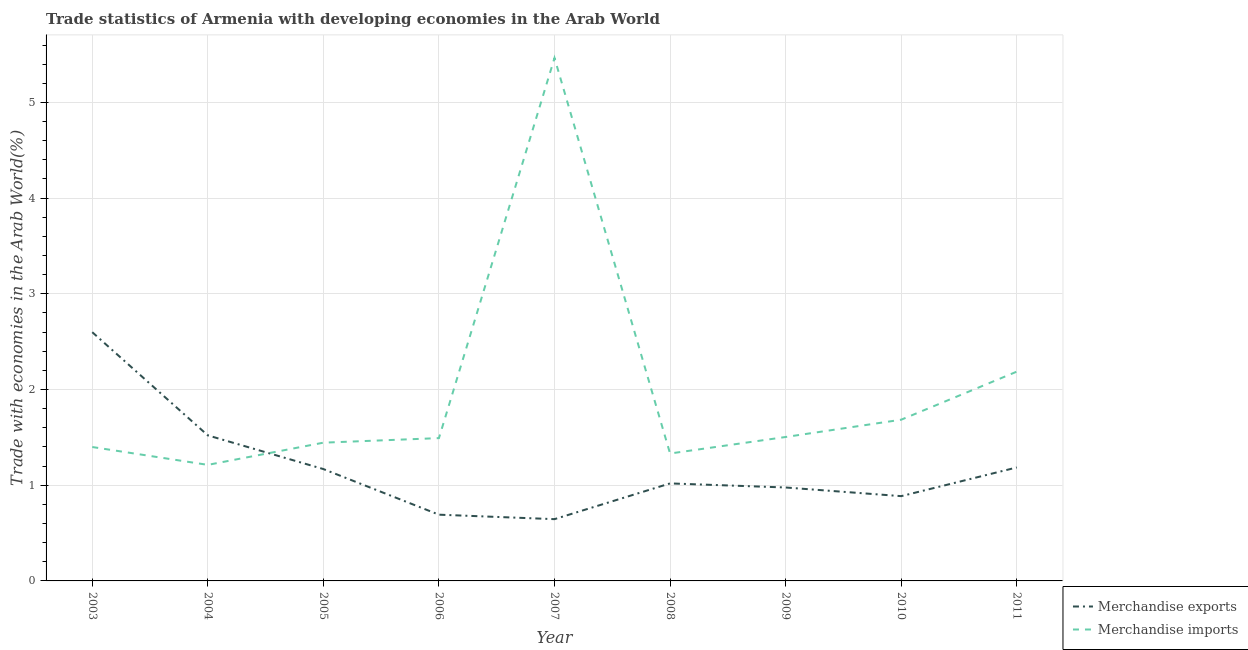How many different coloured lines are there?
Give a very brief answer. 2. What is the merchandise exports in 2011?
Offer a terse response. 1.19. Across all years, what is the maximum merchandise imports?
Offer a terse response. 5.47. Across all years, what is the minimum merchandise imports?
Your answer should be compact. 1.21. In which year was the merchandise imports maximum?
Keep it short and to the point. 2007. In which year was the merchandise exports minimum?
Your response must be concise. 2007. What is the total merchandise exports in the graph?
Keep it short and to the point. 10.69. What is the difference between the merchandise imports in 2007 and that in 2008?
Your answer should be very brief. 4.13. What is the difference between the merchandise imports in 2007 and the merchandise exports in 2005?
Provide a short and direct response. 4.3. What is the average merchandise imports per year?
Give a very brief answer. 1.97. In the year 2010, what is the difference between the merchandise exports and merchandise imports?
Offer a terse response. -0.8. What is the ratio of the merchandise exports in 2003 to that in 2006?
Offer a terse response. 3.76. What is the difference between the highest and the second highest merchandise imports?
Make the answer very short. 3.28. What is the difference between the highest and the lowest merchandise exports?
Your answer should be compact. 1.95. In how many years, is the merchandise exports greater than the average merchandise exports taken over all years?
Your answer should be very brief. 2. Is the merchandise imports strictly less than the merchandise exports over the years?
Offer a very short reply. No. How many lines are there?
Your response must be concise. 2. How many years are there in the graph?
Provide a short and direct response. 9. Does the graph contain any zero values?
Make the answer very short. No. Does the graph contain grids?
Offer a terse response. Yes. How are the legend labels stacked?
Offer a very short reply. Vertical. What is the title of the graph?
Your answer should be very brief. Trade statistics of Armenia with developing economies in the Arab World. What is the label or title of the X-axis?
Provide a succinct answer. Year. What is the label or title of the Y-axis?
Ensure brevity in your answer.  Trade with economies in the Arab World(%). What is the Trade with economies in the Arab World(%) in Merchandise exports in 2003?
Keep it short and to the point. 2.6. What is the Trade with economies in the Arab World(%) in Merchandise imports in 2003?
Offer a very short reply. 1.4. What is the Trade with economies in the Arab World(%) of Merchandise exports in 2004?
Your answer should be compact. 1.52. What is the Trade with economies in the Arab World(%) of Merchandise imports in 2004?
Make the answer very short. 1.21. What is the Trade with economies in the Arab World(%) in Merchandise exports in 2005?
Give a very brief answer. 1.17. What is the Trade with economies in the Arab World(%) of Merchandise imports in 2005?
Offer a very short reply. 1.44. What is the Trade with economies in the Arab World(%) of Merchandise exports in 2006?
Provide a short and direct response. 0.69. What is the Trade with economies in the Arab World(%) in Merchandise imports in 2006?
Make the answer very short. 1.49. What is the Trade with economies in the Arab World(%) of Merchandise exports in 2007?
Keep it short and to the point. 0.65. What is the Trade with economies in the Arab World(%) in Merchandise imports in 2007?
Keep it short and to the point. 5.47. What is the Trade with economies in the Arab World(%) of Merchandise exports in 2008?
Keep it short and to the point. 1.02. What is the Trade with economies in the Arab World(%) of Merchandise imports in 2008?
Provide a succinct answer. 1.33. What is the Trade with economies in the Arab World(%) of Merchandise exports in 2009?
Your answer should be compact. 0.98. What is the Trade with economies in the Arab World(%) of Merchandise imports in 2009?
Your response must be concise. 1.5. What is the Trade with economies in the Arab World(%) of Merchandise exports in 2010?
Your response must be concise. 0.89. What is the Trade with economies in the Arab World(%) in Merchandise imports in 2010?
Your response must be concise. 1.68. What is the Trade with economies in the Arab World(%) of Merchandise exports in 2011?
Provide a succinct answer. 1.19. What is the Trade with economies in the Arab World(%) of Merchandise imports in 2011?
Make the answer very short. 2.19. Across all years, what is the maximum Trade with economies in the Arab World(%) of Merchandise exports?
Ensure brevity in your answer.  2.6. Across all years, what is the maximum Trade with economies in the Arab World(%) of Merchandise imports?
Your response must be concise. 5.47. Across all years, what is the minimum Trade with economies in the Arab World(%) of Merchandise exports?
Make the answer very short. 0.65. Across all years, what is the minimum Trade with economies in the Arab World(%) of Merchandise imports?
Your answer should be compact. 1.21. What is the total Trade with economies in the Arab World(%) of Merchandise exports in the graph?
Your answer should be compact. 10.69. What is the total Trade with economies in the Arab World(%) of Merchandise imports in the graph?
Offer a very short reply. 17.72. What is the difference between the Trade with economies in the Arab World(%) in Merchandise exports in 2003 and that in 2004?
Ensure brevity in your answer.  1.08. What is the difference between the Trade with economies in the Arab World(%) in Merchandise imports in 2003 and that in 2004?
Offer a terse response. 0.19. What is the difference between the Trade with economies in the Arab World(%) of Merchandise exports in 2003 and that in 2005?
Keep it short and to the point. 1.43. What is the difference between the Trade with economies in the Arab World(%) of Merchandise imports in 2003 and that in 2005?
Give a very brief answer. -0.05. What is the difference between the Trade with economies in the Arab World(%) in Merchandise exports in 2003 and that in 2006?
Keep it short and to the point. 1.91. What is the difference between the Trade with economies in the Arab World(%) of Merchandise imports in 2003 and that in 2006?
Give a very brief answer. -0.09. What is the difference between the Trade with economies in the Arab World(%) in Merchandise exports in 2003 and that in 2007?
Your answer should be compact. 1.95. What is the difference between the Trade with economies in the Arab World(%) in Merchandise imports in 2003 and that in 2007?
Provide a succinct answer. -4.07. What is the difference between the Trade with economies in the Arab World(%) of Merchandise exports in 2003 and that in 2008?
Make the answer very short. 1.58. What is the difference between the Trade with economies in the Arab World(%) in Merchandise imports in 2003 and that in 2008?
Your response must be concise. 0.07. What is the difference between the Trade with economies in the Arab World(%) in Merchandise exports in 2003 and that in 2009?
Offer a very short reply. 1.62. What is the difference between the Trade with economies in the Arab World(%) in Merchandise imports in 2003 and that in 2009?
Provide a succinct answer. -0.1. What is the difference between the Trade with economies in the Arab World(%) of Merchandise exports in 2003 and that in 2010?
Your response must be concise. 1.71. What is the difference between the Trade with economies in the Arab World(%) of Merchandise imports in 2003 and that in 2010?
Provide a short and direct response. -0.29. What is the difference between the Trade with economies in the Arab World(%) of Merchandise exports in 2003 and that in 2011?
Provide a short and direct response. 1.41. What is the difference between the Trade with economies in the Arab World(%) of Merchandise imports in 2003 and that in 2011?
Provide a short and direct response. -0.79. What is the difference between the Trade with economies in the Arab World(%) in Merchandise exports in 2004 and that in 2005?
Your response must be concise. 0.35. What is the difference between the Trade with economies in the Arab World(%) of Merchandise imports in 2004 and that in 2005?
Your answer should be compact. -0.23. What is the difference between the Trade with economies in the Arab World(%) in Merchandise exports in 2004 and that in 2006?
Your response must be concise. 0.83. What is the difference between the Trade with economies in the Arab World(%) of Merchandise imports in 2004 and that in 2006?
Your answer should be very brief. -0.28. What is the difference between the Trade with economies in the Arab World(%) of Merchandise exports in 2004 and that in 2007?
Offer a terse response. 0.88. What is the difference between the Trade with economies in the Arab World(%) in Merchandise imports in 2004 and that in 2007?
Ensure brevity in your answer.  -4.25. What is the difference between the Trade with economies in the Arab World(%) in Merchandise exports in 2004 and that in 2008?
Ensure brevity in your answer.  0.5. What is the difference between the Trade with economies in the Arab World(%) in Merchandise imports in 2004 and that in 2008?
Keep it short and to the point. -0.12. What is the difference between the Trade with economies in the Arab World(%) of Merchandise exports in 2004 and that in 2009?
Your answer should be compact. 0.54. What is the difference between the Trade with economies in the Arab World(%) in Merchandise imports in 2004 and that in 2009?
Make the answer very short. -0.29. What is the difference between the Trade with economies in the Arab World(%) in Merchandise exports in 2004 and that in 2010?
Make the answer very short. 0.63. What is the difference between the Trade with economies in the Arab World(%) of Merchandise imports in 2004 and that in 2010?
Your response must be concise. -0.47. What is the difference between the Trade with economies in the Arab World(%) in Merchandise exports in 2004 and that in 2011?
Your response must be concise. 0.34. What is the difference between the Trade with economies in the Arab World(%) of Merchandise imports in 2004 and that in 2011?
Offer a very short reply. -0.97. What is the difference between the Trade with economies in the Arab World(%) of Merchandise exports in 2005 and that in 2006?
Your answer should be compact. 0.48. What is the difference between the Trade with economies in the Arab World(%) of Merchandise imports in 2005 and that in 2006?
Ensure brevity in your answer.  -0.05. What is the difference between the Trade with economies in the Arab World(%) of Merchandise exports in 2005 and that in 2007?
Provide a short and direct response. 0.52. What is the difference between the Trade with economies in the Arab World(%) in Merchandise imports in 2005 and that in 2007?
Your answer should be compact. -4.02. What is the difference between the Trade with economies in the Arab World(%) in Merchandise exports in 2005 and that in 2008?
Offer a terse response. 0.15. What is the difference between the Trade with economies in the Arab World(%) of Merchandise imports in 2005 and that in 2008?
Give a very brief answer. 0.11. What is the difference between the Trade with economies in the Arab World(%) in Merchandise exports in 2005 and that in 2009?
Your response must be concise. 0.19. What is the difference between the Trade with economies in the Arab World(%) in Merchandise imports in 2005 and that in 2009?
Ensure brevity in your answer.  -0.06. What is the difference between the Trade with economies in the Arab World(%) of Merchandise exports in 2005 and that in 2010?
Make the answer very short. 0.28. What is the difference between the Trade with economies in the Arab World(%) of Merchandise imports in 2005 and that in 2010?
Your response must be concise. -0.24. What is the difference between the Trade with economies in the Arab World(%) of Merchandise exports in 2005 and that in 2011?
Offer a terse response. -0.02. What is the difference between the Trade with economies in the Arab World(%) in Merchandise imports in 2005 and that in 2011?
Offer a terse response. -0.74. What is the difference between the Trade with economies in the Arab World(%) in Merchandise exports in 2006 and that in 2007?
Make the answer very short. 0.05. What is the difference between the Trade with economies in the Arab World(%) in Merchandise imports in 2006 and that in 2007?
Provide a succinct answer. -3.97. What is the difference between the Trade with economies in the Arab World(%) in Merchandise exports in 2006 and that in 2008?
Offer a very short reply. -0.33. What is the difference between the Trade with economies in the Arab World(%) in Merchandise imports in 2006 and that in 2008?
Your answer should be compact. 0.16. What is the difference between the Trade with economies in the Arab World(%) in Merchandise exports in 2006 and that in 2009?
Give a very brief answer. -0.28. What is the difference between the Trade with economies in the Arab World(%) in Merchandise imports in 2006 and that in 2009?
Provide a succinct answer. -0.01. What is the difference between the Trade with economies in the Arab World(%) of Merchandise exports in 2006 and that in 2010?
Your answer should be very brief. -0.19. What is the difference between the Trade with economies in the Arab World(%) of Merchandise imports in 2006 and that in 2010?
Offer a terse response. -0.19. What is the difference between the Trade with economies in the Arab World(%) of Merchandise exports in 2006 and that in 2011?
Your response must be concise. -0.49. What is the difference between the Trade with economies in the Arab World(%) in Merchandise imports in 2006 and that in 2011?
Provide a short and direct response. -0.69. What is the difference between the Trade with economies in the Arab World(%) of Merchandise exports in 2007 and that in 2008?
Your answer should be very brief. -0.37. What is the difference between the Trade with economies in the Arab World(%) of Merchandise imports in 2007 and that in 2008?
Offer a terse response. 4.13. What is the difference between the Trade with economies in the Arab World(%) of Merchandise exports in 2007 and that in 2009?
Your response must be concise. -0.33. What is the difference between the Trade with economies in the Arab World(%) of Merchandise imports in 2007 and that in 2009?
Offer a terse response. 3.96. What is the difference between the Trade with economies in the Arab World(%) in Merchandise exports in 2007 and that in 2010?
Offer a terse response. -0.24. What is the difference between the Trade with economies in the Arab World(%) in Merchandise imports in 2007 and that in 2010?
Provide a short and direct response. 3.78. What is the difference between the Trade with economies in the Arab World(%) in Merchandise exports in 2007 and that in 2011?
Your answer should be very brief. -0.54. What is the difference between the Trade with economies in the Arab World(%) in Merchandise imports in 2007 and that in 2011?
Offer a terse response. 3.28. What is the difference between the Trade with economies in the Arab World(%) in Merchandise exports in 2008 and that in 2009?
Give a very brief answer. 0.04. What is the difference between the Trade with economies in the Arab World(%) of Merchandise imports in 2008 and that in 2009?
Ensure brevity in your answer.  -0.17. What is the difference between the Trade with economies in the Arab World(%) in Merchandise exports in 2008 and that in 2010?
Provide a short and direct response. 0.13. What is the difference between the Trade with economies in the Arab World(%) of Merchandise imports in 2008 and that in 2010?
Provide a succinct answer. -0.35. What is the difference between the Trade with economies in the Arab World(%) in Merchandise exports in 2008 and that in 2011?
Offer a terse response. -0.17. What is the difference between the Trade with economies in the Arab World(%) of Merchandise imports in 2008 and that in 2011?
Your response must be concise. -0.86. What is the difference between the Trade with economies in the Arab World(%) in Merchandise exports in 2009 and that in 2010?
Make the answer very short. 0.09. What is the difference between the Trade with economies in the Arab World(%) in Merchandise imports in 2009 and that in 2010?
Your answer should be very brief. -0.18. What is the difference between the Trade with economies in the Arab World(%) in Merchandise exports in 2009 and that in 2011?
Offer a terse response. -0.21. What is the difference between the Trade with economies in the Arab World(%) in Merchandise imports in 2009 and that in 2011?
Provide a short and direct response. -0.68. What is the difference between the Trade with economies in the Arab World(%) in Merchandise exports in 2010 and that in 2011?
Offer a terse response. -0.3. What is the difference between the Trade with economies in the Arab World(%) in Merchandise imports in 2010 and that in 2011?
Your answer should be very brief. -0.5. What is the difference between the Trade with economies in the Arab World(%) of Merchandise exports in 2003 and the Trade with economies in the Arab World(%) of Merchandise imports in 2004?
Your answer should be very brief. 1.39. What is the difference between the Trade with economies in the Arab World(%) of Merchandise exports in 2003 and the Trade with economies in the Arab World(%) of Merchandise imports in 2005?
Your answer should be compact. 1.15. What is the difference between the Trade with economies in the Arab World(%) of Merchandise exports in 2003 and the Trade with economies in the Arab World(%) of Merchandise imports in 2006?
Your answer should be very brief. 1.11. What is the difference between the Trade with economies in the Arab World(%) in Merchandise exports in 2003 and the Trade with economies in the Arab World(%) in Merchandise imports in 2007?
Keep it short and to the point. -2.87. What is the difference between the Trade with economies in the Arab World(%) in Merchandise exports in 2003 and the Trade with economies in the Arab World(%) in Merchandise imports in 2008?
Offer a terse response. 1.27. What is the difference between the Trade with economies in the Arab World(%) of Merchandise exports in 2003 and the Trade with economies in the Arab World(%) of Merchandise imports in 2009?
Provide a short and direct response. 1.1. What is the difference between the Trade with economies in the Arab World(%) in Merchandise exports in 2003 and the Trade with economies in the Arab World(%) in Merchandise imports in 2010?
Give a very brief answer. 0.91. What is the difference between the Trade with economies in the Arab World(%) of Merchandise exports in 2003 and the Trade with economies in the Arab World(%) of Merchandise imports in 2011?
Your answer should be compact. 0.41. What is the difference between the Trade with economies in the Arab World(%) in Merchandise exports in 2004 and the Trade with economies in the Arab World(%) in Merchandise imports in 2005?
Give a very brief answer. 0.08. What is the difference between the Trade with economies in the Arab World(%) in Merchandise exports in 2004 and the Trade with economies in the Arab World(%) in Merchandise imports in 2006?
Ensure brevity in your answer.  0.03. What is the difference between the Trade with economies in the Arab World(%) of Merchandise exports in 2004 and the Trade with economies in the Arab World(%) of Merchandise imports in 2007?
Keep it short and to the point. -3.94. What is the difference between the Trade with economies in the Arab World(%) in Merchandise exports in 2004 and the Trade with economies in the Arab World(%) in Merchandise imports in 2008?
Offer a terse response. 0.19. What is the difference between the Trade with economies in the Arab World(%) of Merchandise exports in 2004 and the Trade with economies in the Arab World(%) of Merchandise imports in 2009?
Give a very brief answer. 0.02. What is the difference between the Trade with economies in the Arab World(%) of Merchandise exports in 2004 and the Trade with economies in the Arab World(%) of Merchandise imports in 2010?
Provide a short and direct response. -0.16. What is the difference between the Trade with economies in the Arab World(%) of Merchandise exports in 2004 and the Trade with economies in the Arab World(%) of Merchandise imports in 2011?
Offer a very short reply. -0.67. What is the difference between the Trade with economies in the Arab World(%) in Merchandise exports in 2005 and the Trade with economies in the Arab World(%) in Merchandise imports in 2006?
Provide a short and direct response. -0.32. What is the difference between the Trade with economies in the Arab World(%) of Merchandise exports in 2005 and the Trade with economies in the Arab World(%) of Merchandise imports in 2007?
Give a very brief answer. -4.3. What is the difference between the Trade with economies in the Arab World(%) in Merchandise exports in 2005 and the Trade with economies in the Arab World(%) in Merchandise imports in 2008?
Your answer should be compact. -0.16. What is the difference between the Trade with economies in the Arab World(%) in Merchandise exports in 2005 and the Trade with economies in the Arab World(%) in Merchandise imports in 2009?
Your response must be concise. -0.34. What is the difference between the Trade with economies in the Arab World(%) in Merchandise exports in 2005 and the Trade with economies in the Arab World(%) in Merchandise imports in 2010?
Ensure brevity in your answer.  -0.52. What is the difference between the Trade with economies in the Arab World(%) in Merchandise exports in 2005 and the Trade with economies in the Arab World(%) in Merchandise imports in 2011?
Offer a terse response. -1.02. What is the difference between the Trade with economies in the Arab World(%) of Merchandise exports in 2006 and the Trade with economies in the Arab World(%) of Merchandise imports in 2007?
Provide a succinct answer. -4.77. What is the difference between the Trade with economies in the Arab World(%) in Merchandise exports in 2006 and the Trade with economies in the Arab World(%) in Merchandise imports in 2008?
Your response must be concise. -0.64. What is the difference between the Trade with economies in the Arab World(%) of Merchandise exports in 2006 and the Trade with economies in the Arab World(%) of Merchandise imports in 2009?
Offer a terse response. -0.81. What is the difference between the Trade with economies in the Arab World(%) in Merchandise exports in 2006 and the Trade with economies in the Arab World(%) in Merchandise imports in 2010?
Provide a short and direct response. -0.99. What is the difference between the Trade with economies in the Arab World(%) of Merchandise exports in 2006 and the Trade with economies in the Arab World(%) of Merchandise imports in 2011?
Make the answer very short. -1.49. What is the difference between the Trade with economies in the Arab World(%) in Merchandise exports in 2007 and the Trade with economies in the Arab World(%) in Merchandise imports in 2008?
Provide a short and direct response. -0.69. What is the difference between the Trade with economies in the Arab World(%) of Merchandise exports in 2007 and the Trade with economies in the Arab World(%) of Merchandise imports in 2009?
Make the answer very short. -0.86. What is the difference between the Trade with economies in the Arab World(%) of Merchandise exports in 2007 and the Trade with economies in the Arab World(%) of Merchandise imports in 2010?
Provide a short and direct response. -1.04. What is the difference between the Trade with economies in the Arab World(%) of Merchandise exports in 2007 and the Trade with economies in the Arab World(%) of Merchandise imports in 2011?
Provide a succinct answer. -1.54. What is the difference between the Trade with economies in the Arab World(%) of Merchandise exports in 2008 and the Trade with economies in the Arab World(%) of Merchandise imports in 2009?
Your response must be concise. -0.48. What is the difference between the Trade with economies in the Arab World(%) of Merchandise exports in 2008 and the Trade with economies in the Arab World(%) of Merchandise imports in 2010?
Your answer should be very brief. -0.67. What is the difference between the Trade with economies in the Arab World(%) of Merchandise exports in 2008 and the Trade with economies in the Arab World(%) of Merchandise imports in 2011?
Your answer should be very brief. -1.17. What is the difference between the Trade with economies in the Arab World(%) in Merchandise exports in 2009 and the Trade with economies in the Arab World(%) in Merchandise imports in 2010?
Offer a terse response. -0.71. What is the difference between the Trade with economies in the Arab World(%) of Merchandise exports in 2009 and the Trade with economies in the Arab World(%) of Merchandise imports in 2011?
Provide a short and direct response. -1.21. What is the difference between the Trade with economies in the Arab World(%) in Merchandise exports in 2010 and the Trade with economies in the Arab World(%) in Merchandise imports in 2011?
Provide a succinct answer. -1.3. What is the average Trade with economies in the Arab World(%) in Merchandise exports per year?
Your response must be concise. 1.19. What is the average Trade with economies in the Arab World(%) of Merchandise imports per year?
Your response must be concise. 1.97. In the year 2003, what is the difference between the Trade with economies in the Arab World(%) of Merchandise exports and Trade with economies in the Arab World(%) of Merchandise imports?
Provide a succinct answer. 1.2. In the year 2004, what is the difference between the Trade with economies in the Arab World(%) of Merchandise exports and Trade with economies in the Arab World(%) of Merchandise imports?
Your answer should be compact. 0.31. In the year 2005, what is the difference between the Trade with economies in the Arab World(%) in Merchandise exports and Trade with economies in the Arab World(%) in Merchandise imports?
Make the answer very short. -0.28. In the year 2006, what is the difference between the Trade with economies in the Arab World(%) in Merchandise exports and Trade with economies in the Arab World(%) in Merchandise imports?
Your answer should be compact. -0.8. In the year 2007, what is the difference between the Trade with economies in the Arab World(%) in Merchandise exports and Trade with economies in the Arab World(%) in Merchandise imports?
Your response must be concise. -4.82. In the year 2008, what is the difference between the Trade with economies in the Arab World(%) in Merchandise exports and Trade with economies in the Arab World(%) in Merchandise imports?
Provide a short and direct response. -0.31. In the year 2009, what is the difference between the Trade with economies in the Arab World(%) of Merchandise exports and Trade with economies in the Arab World(%) of Merchandise imports?
Keep it short and to the point. -0.53. In the year 2010, what is the difference between the Trade with economies in the Arab World(%) in Merchandise exports and Trade with economies in the Arab World(%) in Merchandise imports?
Ensure brevity in your answer.  -0.8. In the year 2011, what is the difference between the Trade with economies in the Arab World(%) of Merchandise exports and Trade with economies in the Arab World(%) of Merchandise imports?
Make the answer very short. -1. What is the ratio of the Trade with economies in the Arab World(%) in Merchandise exports in 2003 to that in 2004?
Offer a very short reply. 1.71. What is the ratio of the Trade with economies in the Arab World(%) in Merchandise imports in 2003 to that in 2004?
Make the answer very short. 1.15. What is the ratio of the Trade with economies in the Arab World(%) in Merchandise exports in 2003 to that in 2005?
Give a very brief answer. 2.22. What is the ratio of the Trade with economies in the Arab World(%) in Merchandise imports in 2003 to that in 2005?
Ensure brevity in your answer.  0.97. What is the ratio of the Trade with economies in the Arab World(%) in Merchandise exports in 2003 to that in 2006?
Give a very brief answer. 3.76. What is the ratio of the Trade with economies in the Arab World(%) of Merchandise imports in 2003 to that in 2006?
Provide a succinct answer. 0.94. What is the ratio of the Trade with economies in the Arab World(%) in Merchandise exports in 2003 to that in 2007?
Your answer should be compact. 4.03. What is the ratio of the Trade with economies in the Arab World(%) in Merchandise imports in 2003 to that in 2007?
Ensure brevity in your answer.  0.26. What is the ratio of the Trade with economies in the Arab World(%) of Merchandise exports in 2003 to that in 2008?
Give a very brief answer. 2.55. What is the ratio of the Trade with economies in the Arab World(%) in Merchandise imports in 2003 to that in 2008?
Make the answer very short. 1.05. What is the ratio of the Trade with economies in the Arab World(%) in Merchandise exports in 2003 to that in 2009?
Your answer should be compact. 2.66. What is the ratio of the Trade with economies in the Arab World(%) in Merchandise imports in 2003 to that in 2009?
Make the answer very short. 0.93. What is the ratio of the Trade with economies in the Arab World(%) in Merchandise exports in 2003 to that in 2010?
Your answer should be very brief. 2.93. What is the ratio of the Trade with economies in the Arab World(%) of Merchandise imports in 2003 to that in 2010?
Your answer should be compact. 0.83. What is the ratio of the Trade with economies in the Arab World(%) of Merchandise exports in 2003 to that in 2011?
Offer a terse response. 2.19. What is the ratio of the Trade with economies in the Arab World(%) in Merchandise imports in 2003 to that in 2011?
Make the answer very short. 0.64. What is the ratio of the Trade with economies in the Arab World(%) of Merchandise exports in 2004 to that in 2005?
Your response must be concise. 1.3. What is the ratio of the Trade with economies in the Arab World(%) in Merchandise imports in 2004 to that in 2005?
Give a very brief answer. 0.84. What is the ratio of the Trade with economies in the Arab World(%) in Merchandise exports in 2004 to that in 2006?
Provide a succinct answer. 2.2. What is the ratio of the Trade with economies in the Arab World(%) of Merchandise imports in 2004 to that in 2006?
Keep it short and to the point. 0.81. What is the ratio of the Trade with economies in the Arab World(%) in Merchandise exports in 2004 to that in 2007?
Offer a very short reply. 2.36. What is the ratio of the Trade with economies in the Arab World(%) of Merchandise imports in 2004 to that in 2007?
Your answer should be compact. 0.22. What is the ratio of the Trade with economies in the Arab World(%) of Merchandise exports in 2004 to that in 2008?
Provide a short and direct response. 1.49. What is the ratio of the Trade with economies in the Arab World(%) of Merchandise imports in 2004 to that in 2008?
Your answer should be very brief. 0.91. What is the ratio of the Trade with economies in the Arab World(%) of Merchandise exports in 2004 to that in 2009?
Provide a short and direct response. 1.56. What is the ratio of the Trade with economies in the Arab World(%) in Merchandise imports in 2004 to that in 2009?
Your response must be concise. 0.81. What is the ratio of the Trade with economies in the Arab World(%) in Merchandise exports in 2004 to that in 2010?
Provide a succinct answer. 1.72. What is the ratio of the Trade with economies in the Arab World(%) of Merchandise imports in 2004 to that in 2010?
Offer a very short reply. 0.72. What is the ratio of the Trade with economies in the Arab World(%) in Merchandise exports in 2004 to that in 2011?
Provide a short and direct response. 1.28. What is the ratio of the Trade with economies in the Arab World(%) in Merchandise imports in 2004 to that in 2011?
Make the answer very short. 0.55. What is the ratio of the Trade with economies in the Arab World(%) in Merchandise exports in 2005 to that in 2006?
Make the answer very short. 1.69. What is the ratio of the Trade with economies in the Arab World(%) of Merchandise exports in 2005 to that in 2007?
Your answer should be compact. 1.81. What is the ratio of the Trade with economies in the Arab World(%) of Merchandise imports in 2005 to that in 2007?
Your answer should be very brief. 0.26. What is the ratio of the Trade with economies in the Arab World(%) in Merchandise exports in 2005 to that in 2008?
Ensure brevity in your answer.  1.15. What is the ratio of the Trade with economies in the Arab World(%) in Merchandise imports in 2005 to that in 2008?
Provide a succinct answer. 1.08. What is the ratio of the Trade with economies in the Arab World(%) of Merchandise exports in 2005 to that in 2009?
Offer a terse response. 1.2. What is the ratio of the Trade with economies in the Arab World(%) of Merchandise imports in 2005 to that in 2009?
Offer a very short reply. 0.96. What is the ratio of the Trade with economies in the Arab World(%) in Merchandise exports in 2005 to that in 2010?
Your answer should be compact. 1.32. What is the ratio of the Trade with economies in the Arab World(%) of Merchandise imports in 2005 to that in 2010?
Your response must be concise. 0.86. What is the ratio of the Trade with economies in the Arab World(%) in Merchandise exports in 2005 to that in 2011?
Provide a succinct answer. 0.99. What is the ratio of the Trade with economies in the Arab World(%) of Merchandise imports in 2005 to that in 2011?
Give a very brief answer. 0.66. What is the ratio of the Trade with economies in the Arab World(%) in Merchandise exports in 2006 to that in 2007?
Your response must be concise. 1.07. What is the ratio of the Trade with economies in the Arab World(%) in Merchandise imports in 2006 to that in 2007?
Your answer should be compact. 0.27. What is the ratio of the Trade with economies in the Arab World(%) of Merchandise exports in 2006 to that in 2008?
Provide a short and direct response. 0.68. What is the ratio of the Trade with economies in the Arab World(%) of Merchandise imports in 2006 to that in 2008?
Keep it short and to the point. 1.12. What is the ratio of the Trade with economies in the Arab World(%) in Merchandise exports in 2006 to that in 2009?
Provide a short and direct response. 0.71. What is the ratio of the Trade with economies in the Arab World(%) in Merchandise exports in 2006 to that in 2010?
Make the answer very short. 0.78. What is the ratio of the Trade with economies in the Arab World(%) in Merchandise imports in 2006 to that in 2010?
Keep it short and to the point. 0.89. What is the ratio of the Trade with economies in the Arab World(%) in Merchandise exports in 2006 to that in 2011?
Provide a succinct answer. 0.58. What is the ratio of the Trade with economies in the Arab World(%) of Merchandise imports in 2006 to that in 2011?
Offer a terse response. 0.68. What is the ratio of the Trade with economies in the Arab World(%) in Merchandise exports in 2007 to that in 2008?
Provide a succinct answer. 0.63. What is the ratio of the Trade with economies in the Arab World(%) of Merchandise imports in 2007 to that in 2008?
Keep it short and to the point. 4.1. What is the ratio of the Trade with economies in the Arab World(%) in Merchandise exports in 2007 to that in 2009?
Provide a succinct answer. 0.66. What is the ratio of the Trade with economies in the Arab World(%) in Merchandise imports in 2007 to that in 2009?
Provide a short and direct response. 3.63. What is the ratio of the Trade with economies in the Arab World(%) of Merchandise exports in 2007 to that in 2010?
Make the answer very short. 0.73. What is the ratio of the Trade with economies in the Arab World(%) of Merchandise imports in 2007 to that in 2010?
Provide a short and direct response. 3.24. What is the ratio of the Trade with economies in the Arab World(%) in Merchandise exports in 2007 to that in 2011?
Offer a terse response. 0.54. What is the ratio of the Trade with economies in the Arab World(%) in Merchandise imports in 2007 to that in 2011?
Provide a succinct answer. 2.5. What is the ratio of the Trade with economies in the Arab World(%) in Merchandise exports in 2008 to that in 2009?
Provide a short and direct response. 1.04. What is the ratio of the Trade with economies in the Arab World(%) of Merchandise imports in 2008 to that in 2009?
Your answer should be very brief. 0.89. What is the ratio of the Trade with economies in the Arab World(%) of Merchandise exports in 2008 to that in 2010?
Your response must be concise. 1.15. What is the ratio of the Trade with economies in the Arab World(%) of Merchandise imports in 2008 to that in 2010?
Ensure brevity in your answer.  0.79. What is the ratio of the Trade with economies in the Arab World(%) in Merchandise exports in 2008 to that in 2011?
Keep it short and to the point. 0.86. What is the ratio of the Trade with economies in the Arab World(%) in Merchandise imports in 2008 to that in 2011?
Provide a succinct answer. 0.61. What is the ratio of the Trade with economies in the Arab World(%) in Merchandise exports in 2009 to that in 2010?
Provide a short and direct response. 1.1. What is the ratio of the Trade with economies in the Arab World(%) of Merchandise imports in 2009 to that in 2010?
Your answer should be very brief. 0.89. What is the ratio of the Trade with economies in the Arab World(%) in Merchandise exports in 2009 to that in 2011?
Your answer should be compact. 0.82. What is the ratio of the Trade with economies in the Arab World(%) in Merchandise imports in 2009 to that in 2011?
Your response must be concise. 0.69. What is the ratio of the Trade with economies in the Arab World(%) of Merchandise exports in 2010 to that in 2011?
Offer a terse response. 0.75. What is the ratio of the Trade with economies in the Arab World(%) in Merchandise imports in 2010 to that in 2011?
Make the answer very short. 0.77. What is the difference between the highest and the second highest Trade with economies in the Arab World(%) in Merchandise exports?
Make the answer very short. 1.08. What is the difference between the highest and the second highest Trade with economies in the Arab World(%) of Merchandise imports?
Offer a terse response. 3.28. What is the difference between the highest and the lowest Trade with economies in the Arab World(%) of Merchandise exports?
Provide a succinct answer. 1.95. What is the difference between the highest and the lowest Trade with economies in the Arab World(%) in Merchandise imports?
Offer a terse response. 4.25. 